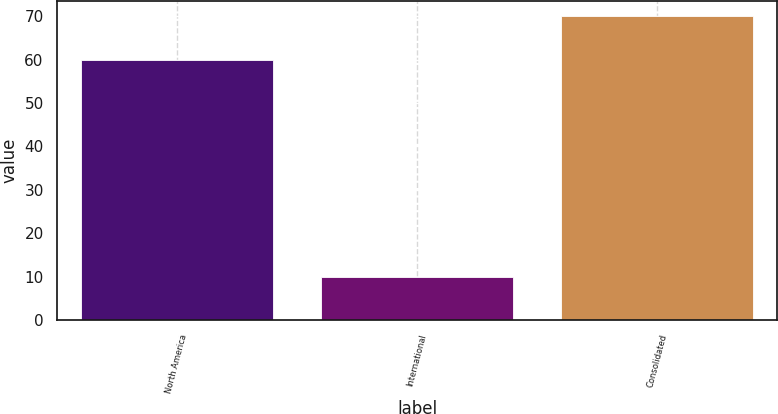Convert chart to OTSL. <chart><loc_0><loc_0><loc_500><loc_500><bar_chart><fcel>North America<fcel>International<fcel>Consolidated<nl><fcel>60<fcel>10<fcel>70<nl></chart> 